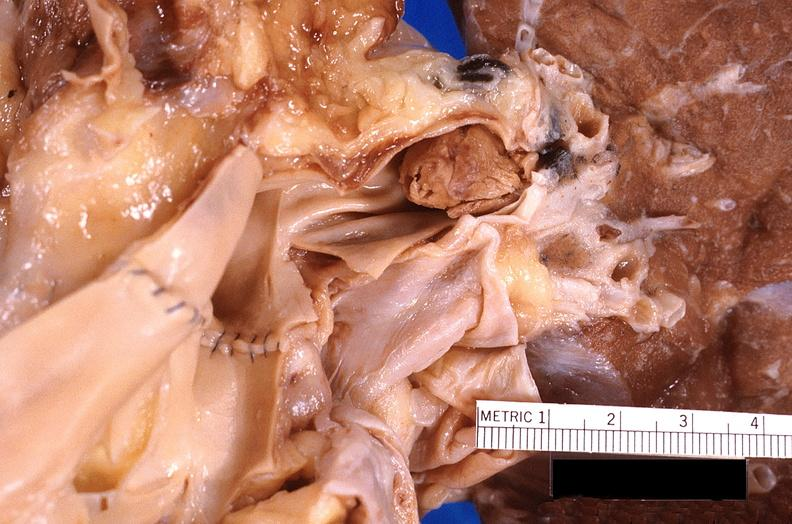does this image show thromboembolus from leg veins in pulmonary artery?
Answer the question using a single word or phrase. Yes 